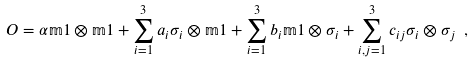Convert formula to latex. <formula><loc_0><loc_0><loc_500><loc_500>O = \alpha \mathbb { m } { 1 } \otimes \mathbb { m } { 1 } + \sum _ { i = 1 } ^ { 3 } a _ { i } \sigma _ { i } \otimes \mathbb { m } { 1 } + \sum _ { i = 1 } ^ { 3 } b _ { i } \mathbb { m } { 1 } \otimes \sigma _ { i } + \sum _ { i , j = 1 } ^ { 3 } c _ { i j } \sigma _ { i } \otimes \sigma _ { j } \ ,</formula> 